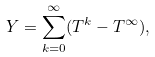Convert formula to latex. <formula><loc_0><loc_0><loc_500><loc_500>Y = \sum _ { k = 0 } ^ { \infty } ( T ^ { k } - T ^ { \infty } ) ,</formula> 